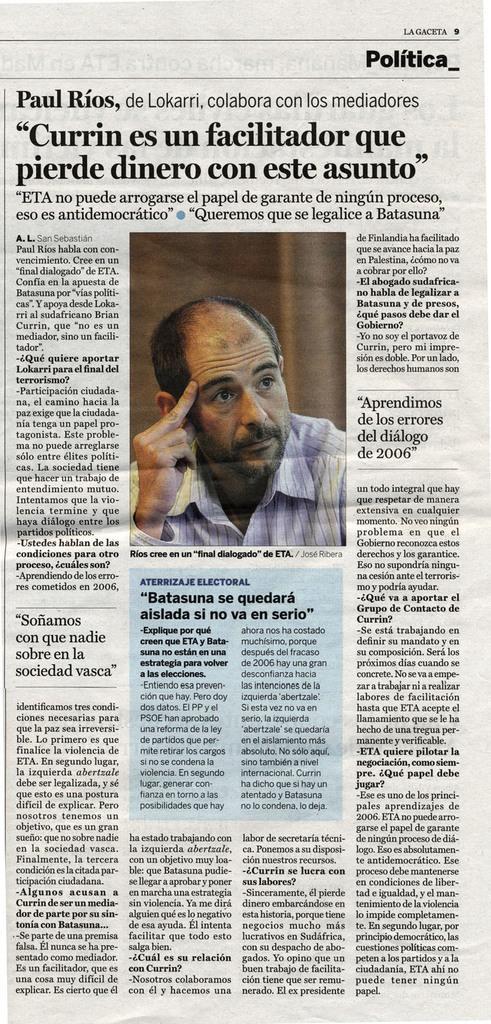Could you give a brief overview of what you see in this image? In this image we can see a paper with the text and also the person image. 